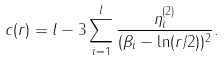Convert formula to latex. <formula><loc_0><loc_0><loc_500><loc_500>c ( r ) = l - 3 \sum _ { i = 1 } ^ { l } \frac { \eta _ { i } ^ { ( 2 ) } } { ( \beta _ { i } - \ln ( r / 2 ) ) ^ { 2 } } .</formula> 